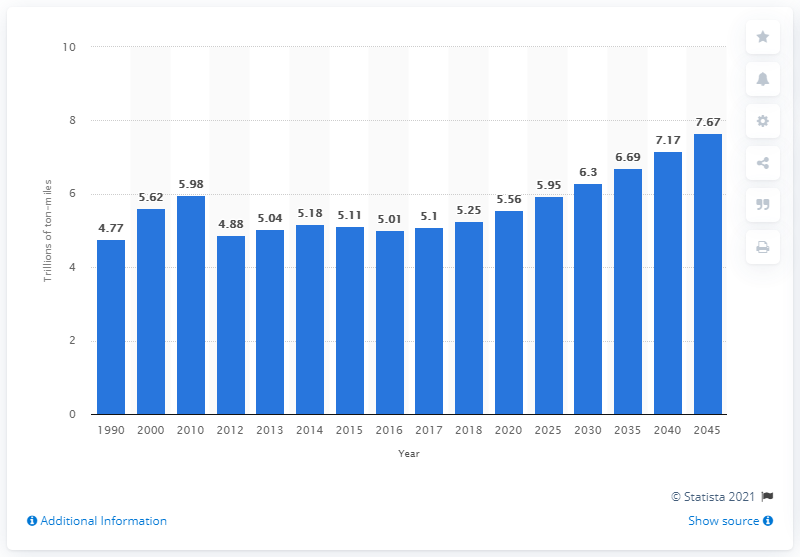Give some essential details in this illustration. In 2018, there were approximately 5.25 million ton-miles of freight. The timeline predicts that by the year 2045, the total amount of freight transported in the United States will reach 2045 tons-miles. 